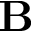<formula> <loc_0><loc_0><loc_500><loc_500>{ B }</formula> 